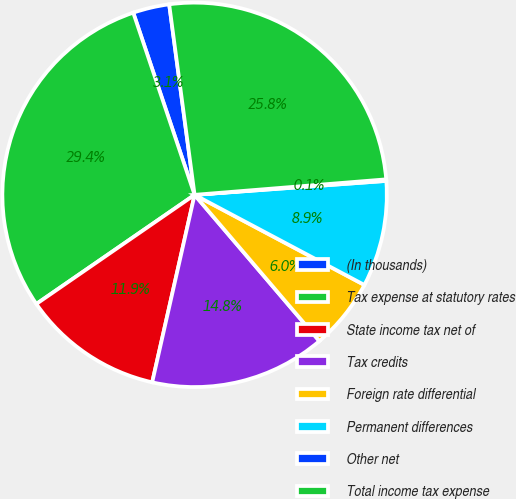Convert chart to OTSL. <chart><loc_0><loc_0><loc_500><loc_500><pie_chart><fcel>(In thousands)<fcel>Tax expense at statutory rates<fcel>State income tax net of<fcel>Tax credits<fcel>Foreign rate differential<fcel>Permanent differences<fcel>Other net<fcel>Total income tax expense<nl><fcel>3.06%<fcel>29.43%<fcel>11.85%<fcel>14.78%<fcel>5.99%<fcel>8.92%<fcel>0.13%<fcel>25.82%<nl></chart> 